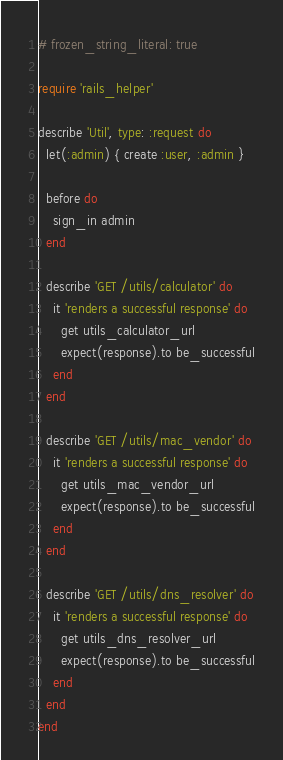<code> <loc_0><loc_0><loc_500><loc_500><_Ruby_># frozen_string_literal: true

require 'rails_helper'

describe 'Util', type: :request do
  let(:admin) { create :user, :admin }

  before do
    sign_in admin
  end

  describe 'GET /utils/calculator' do
    it 'renders a successful response' do
      get utils_calculator_url
      expect(response).to be_successful
    end
  end

  describe 'GET /utils/mac_vendor' do
    it 'renders a successful response' do
      get utils_mac_vendor_url
      expect(response).to be_successful
    end
  end

  describe 'GET /utils/dns_resolver' do
    it 'renders a successful response' do
      get utils_dns_resolver_url
      expect(response).to be_successful
    end
  end
end
</code> 